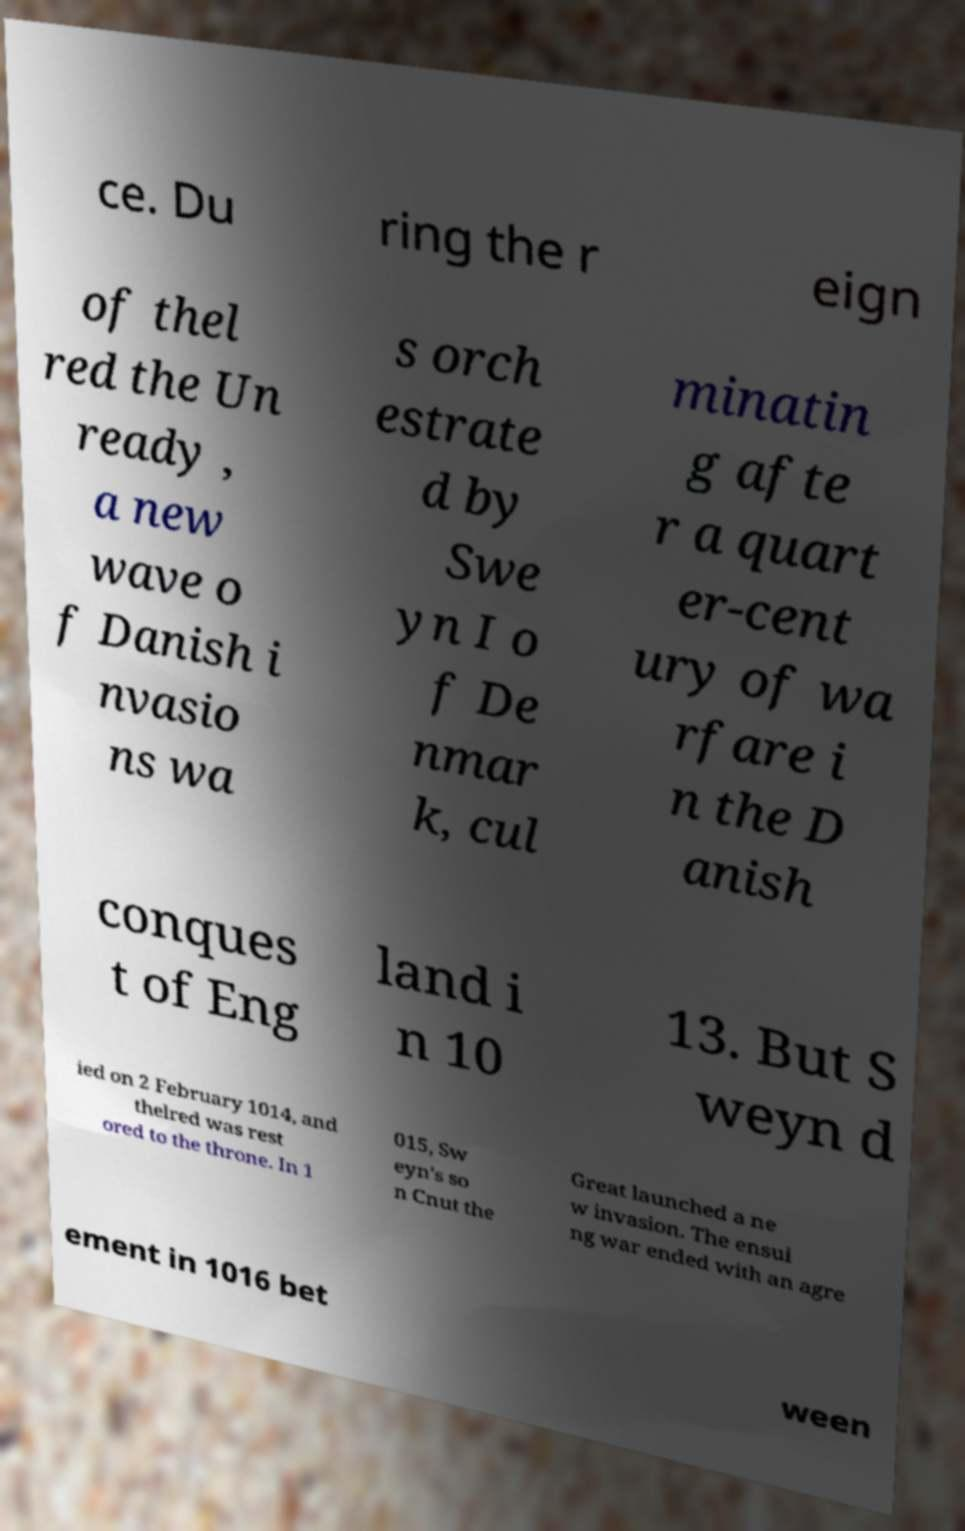For documentation purposes, I need the text within this image transcribed. Could you provide that? ce. Du ring the r eign of thel red the Un ready , a new wave o f Danish i nvasio ns wa s orch estrate d by Swe yn I o f De nmar k, cul minatin g afte r a quart er-cent ury of wa rfare i n the D anish conques t of Eng land i n 10 13. But S weyn d ied on 2 February 1014, and thelred was rest ored to the throne. In 1 015, Sw eyn's so n Cnut the Great launched a ne w invasion. The ensui ng war ended with an agre ement in 1016 bet ween 